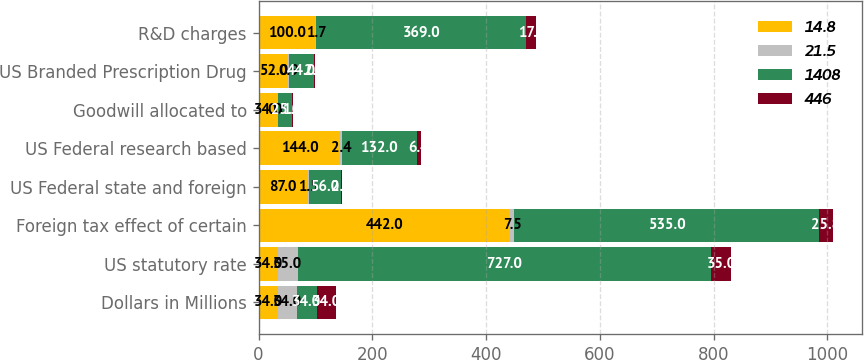Convert chart to OTSL. <chart><loc_0><loc_0><loc_500><loc_500><stacked_bar_chart><ecel><fcel>Dollars in Millions<fcel>US statutory rate<fcel>Foreign tax effect of certain<fcel>US Federal state and foreign<fcel>US Federal research based<fcel>Goodwill allocated to<fcel>US Branded Prescription Drug<fcel>R&D charges<nl><fcel>14.8<fcel>34<fcel>34<fcel>442<fcel>87<fcel>144<fcel>34<fcel>52<fcel>100<nl><fcel>21.5<fcel>34<fcel>35<fcel>7.5<fcel>1.5<fcel>2.4<fcel>0.6<fcel>0.9<fcel>1.7<nl><fcel>1408<fcel>34<fcel>727<fcel>535<fcel>56<fcel>132<fcel>25<fcel>44<fcel>369<nl><fcel>446<fcel>34<fcel>35<fcel>25.8<fcel>2.7<fcel>6.4<fcel>1.2<fcel>2.1<fcel>17.8<nl></chart> 